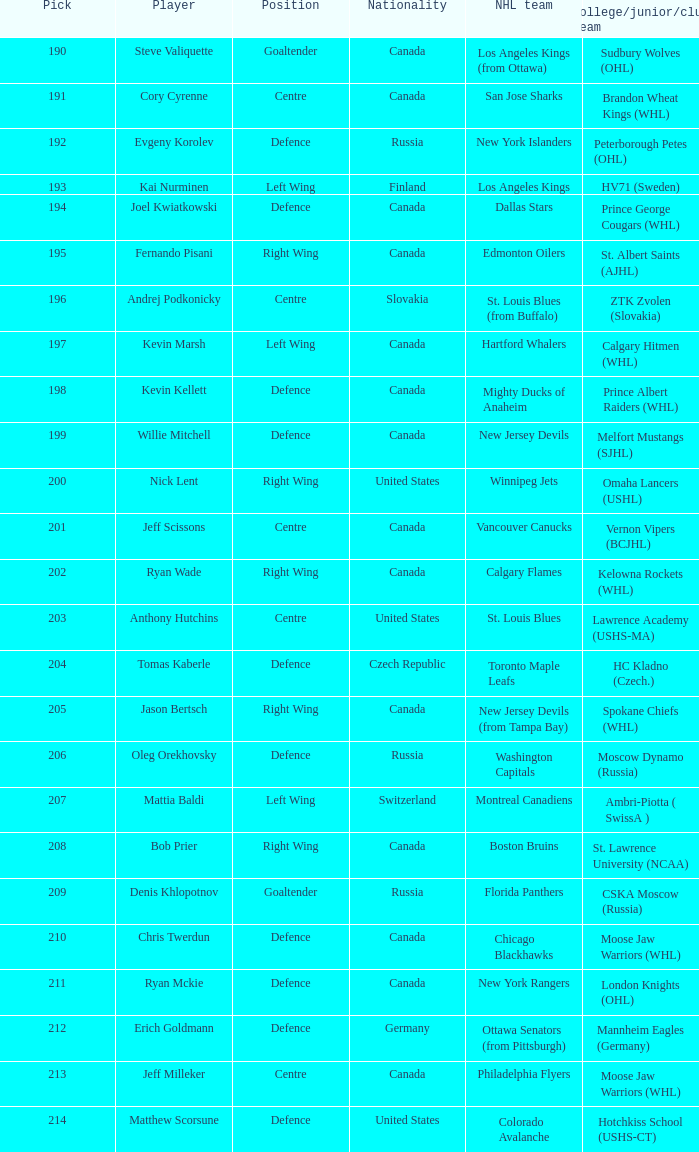What is the selection for matthew scorsune? 214.0. 